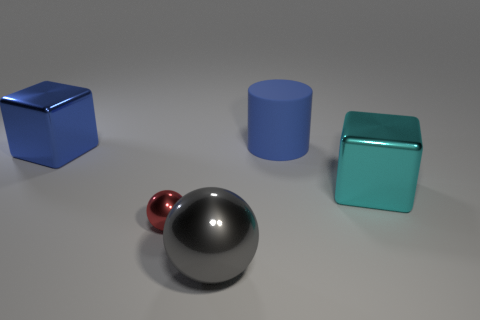Add 3 green metal cubes. How many objects exist? 8 Subtract all gray spheres. How many spheres are left? 1 Subtract all cylinders. How many objects are left? 4 Subtract 1 cylinders. How many cylinders are left? 0 Subtract all large green rubber blocks. Subtract all cylinders. How many objects are left? 4 Add 4 big rubber objects. How many big rubber objects are left? 5 Add 3 big gray metallic things. How many big gray metallic things exist? 4 Subtract 0 blue spheres. How many objects are left? 5 Subtract all yellow blocks. Subtract all gray balls. How many blocks are left? 2 